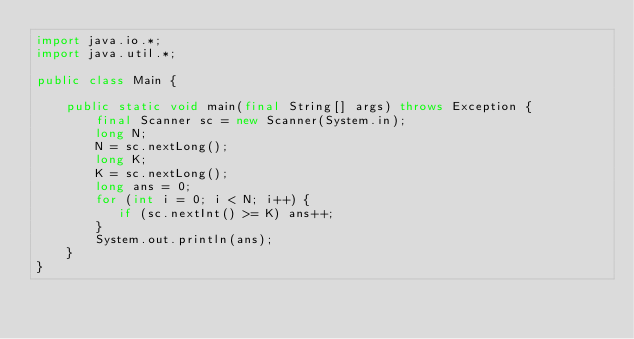<code> <loc_0><loc_0><loc_500><loc_500><_Java_>import java.io.*;
import java.util.*;

public class Main {

    public static void main(final String[] args) throws Exception {
        final Scanner sc = new Scanner(System.in);
        long N;
        N = sc.nextLong();
        long K;
        K = sc.nextLong();
        long ans = 0;
        for (int i = 0; i < N; i++) {
           if (sc.nextInt() >= K) ans++;
        }
        System.out.println(ans);
    }
}
</code> 